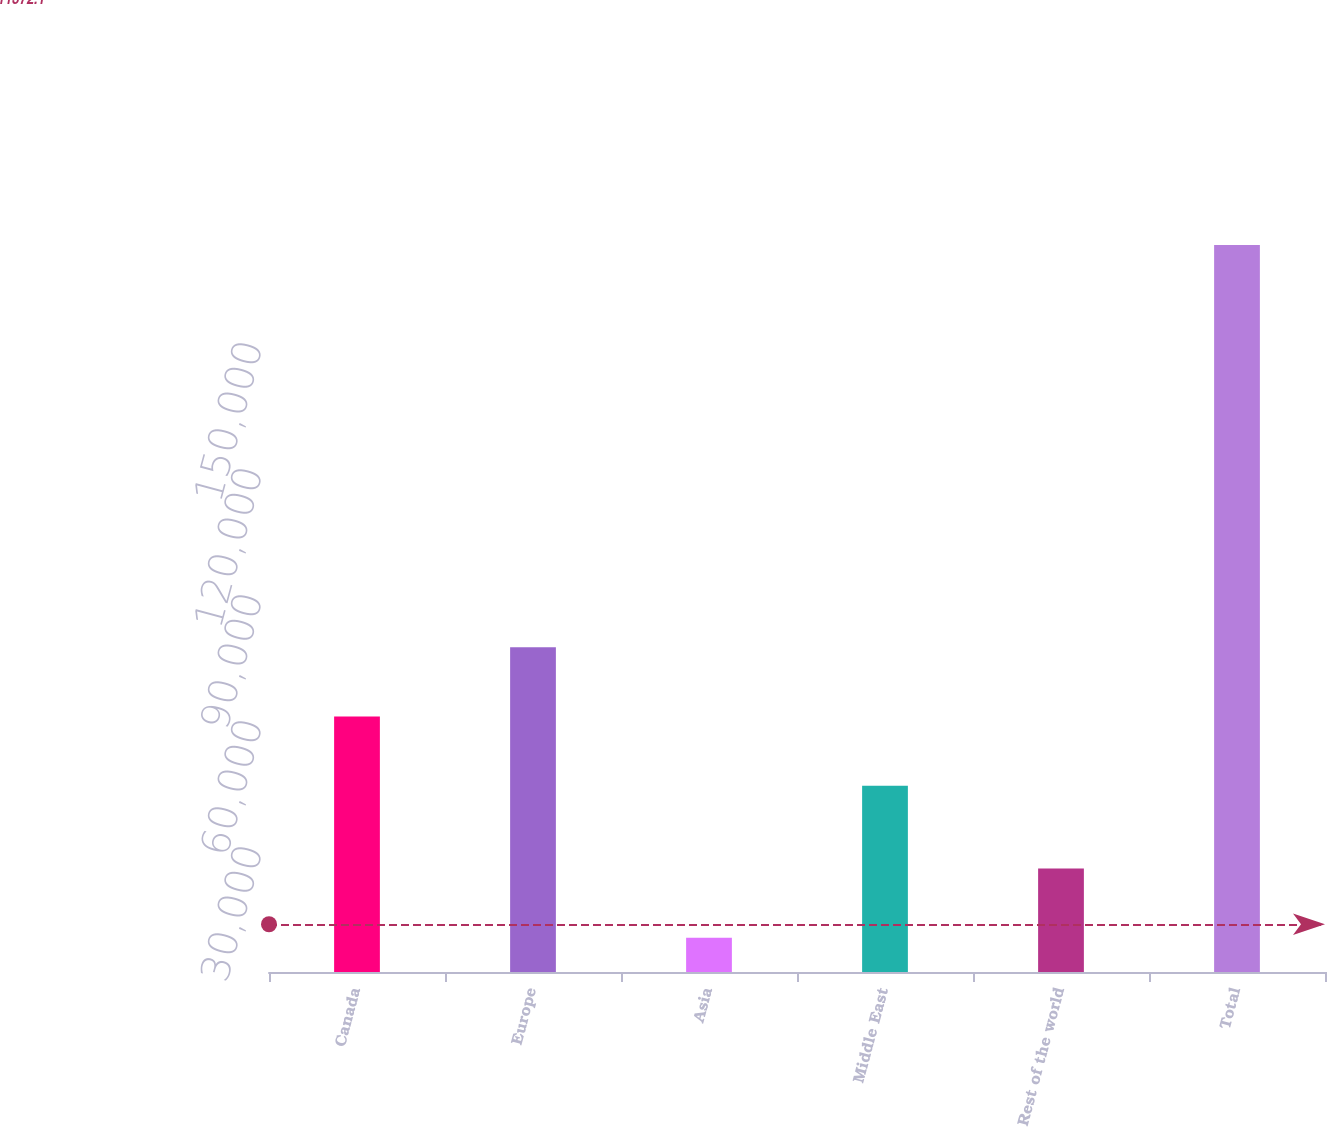<chart> <loc_0><loc_0><loc_500><loc_500><bar_chart><fcel>Canada<fcel>Europe<fcel>Asia<fcel>Middle East<fcel>Rest of the world<fcel>Total<nl><fcel>60839.5<fcel>77338<fcel>8134<fcel>44341<fcel>24632.5<fcel>173119<nl></chart> 